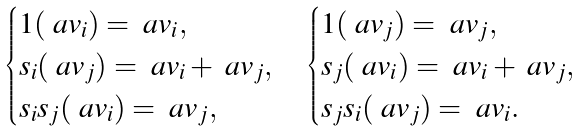Convert formula to latex. <formula><loc_0><loc_0><loc_500><loc_500>\begin{cases} 1 ( \ a v _ { i } ) = \ a v _ { i } , \\ s _ { i } ( \ a v _ { j } ) = \ a v _ { i } + \ a v _ { j } , \\ s _ { i } s _ { j } ( \ a v _ { i } ) = \ a v _ { j } , \end{cases} \begin{cases} 1 ( \ a v _ { j } ) = \ a v _ { j } , \\ s _ { j } ( \ a v _ { i } ) = \ a v _ { i } + \ a v _ { j } , \\ s _ { j } s _ { i } ( \ a v _ { j } ) = \ a v _ { i } . \end{cases}</formula> 